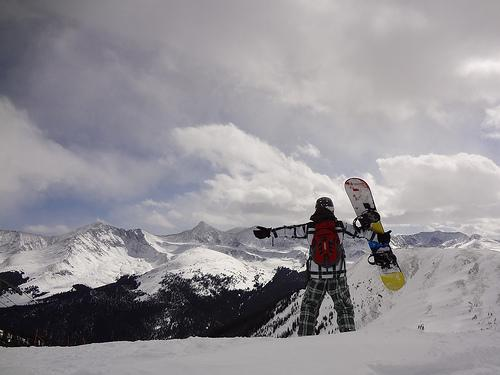Write a brief overview of the individual's appearance and actions, as well as the environmental setting in the image. A snowboarder wearing a helmet, warm clothing, and a red backpack, grips a white and yellow snowboard in their black-gloved hands while standing on a snowy mountain scene with blue sky and clouds. Provide a concise description of the main elements and situation in the image. A person snowboarding on a mountaintop, wearing warm clothing, and holding a white and yellow snowboard, with a red backpack, surrounded by snow-covered mountains and blue sky with white clouds. Provide a brief description of the individual and what they are doing in the image, with a focus on their attire and the environmental setting. A person wearing a helmet, gloves, and a red backpack, stands on a picturesque snowy mountain while holding a white and yellow snowboard, surrounded by snow-covered peaks and a blue sky with clouds. Briefly describe the scene depicted in the image, paying attention to the person's apparel, gear, and surroundings. A snowboarder dressed in a white and black jacket and plaid pants, carrying a red backpack, holds a white and yellow snowboard in front of snow-covered mountains and a blue sky with clouds. Summarize the key actions and components of the image that includes a person on a snowy mountain in a single sentence. A person wearing a red backpack and snowboarding attire stands atop a snowy mountain, holding their white and yellow snowboard in front of a beautiful sky and mountainous backdrop. Provide a succinct description of the main subject in the image, their attire and equipment, and the background setting. A person clad in snowboarding gear, including a helmet and gloves, with a red backpack, stands in front of a breathtaking snow-covered mountain range, holding their white and yellow snowboard. Describe the primary focus of the image and the individual's position in relation to the backdrop. A person on a winter vacation stands holding a white and yellow snowboard with a red backpack on their back, in front of a majestic snowy mountain landscape under blue sky filled with white clouds. Detail the individual's appearance, the object they are holding, and the scenic environment in the image. A person wearing warm clothing and a red backpack stands on a snowy mountaintop, holding a white and yellow snowboard, with snow-covered mountains and blue sky punctuated by clouds as the backdrop. Describe the person's attire and demeanor in the image, along with their surroundings. A snowboarder wearing a white and black jacket, plaid pants, gloves, and a red backpack, stands amidst a striking snow-covered mountaintop landscape with a blue sky and white clouds, proudly carrying their white and yellow snowboard. In a single sentence, convey the primary focus of the image, including the individual's attire and location. A person dressed for winter sports and wearing a red backpack holds a white and yellow snowboard aloft on a snow-covered mountaintop with a peaceful blue sky and white clouds in the background. 